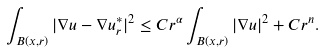Convert formula to latex. <formula><loc_0><loc_0><loc_500><loc_500>\int _ { B ( x , r ) } | \nabla u - \nabla u _ { r } ^ { * } | ^ { 2 } \leq C r ^ { \alpha } \int _ { B ( x , r ) } | \nabla u | ^ { 2 } + C r ^ { n } .</formula> 